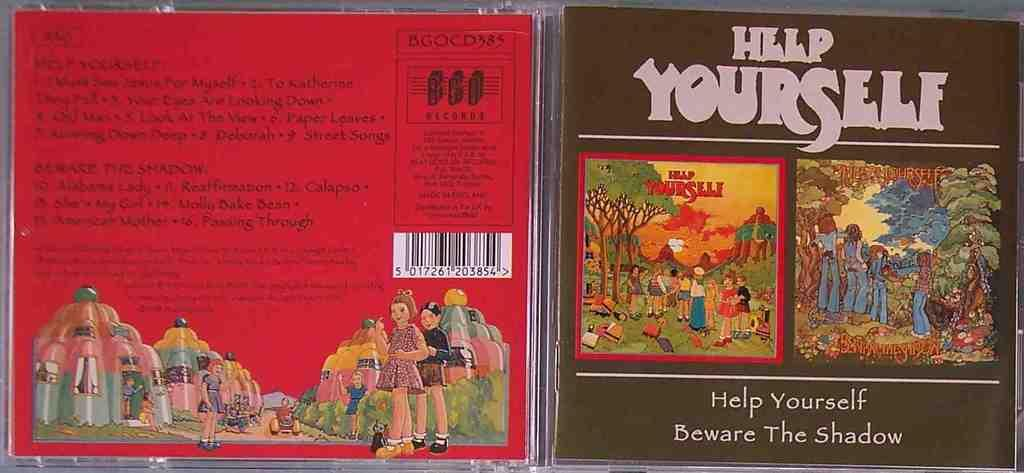<image>
Create a compact narrative representing the image presented. A cd is titled Help Yourself and has pictures on the front and back. 